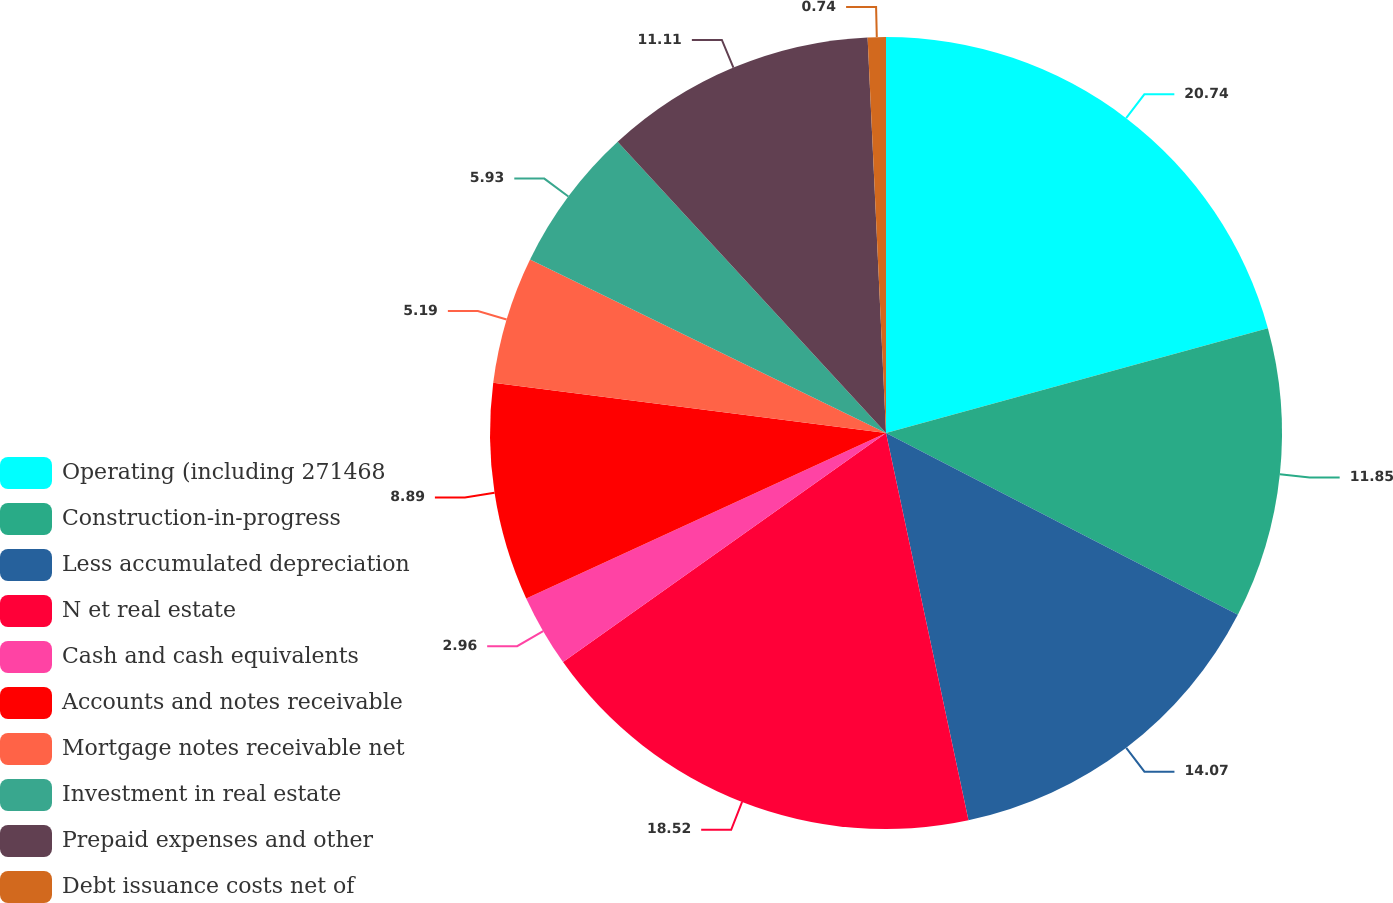Convert chart. <chart><loc_0><loc_0><loc_500><loc_500><pie_chart><fcel>Operating (including 271468<fcel>Construction-in-progress<fcel>Less accumulated depreciation<fcel>N et real estate<fcel>Cash and cash equivalents<fcel>Accounts and notes receivable<fcel>Mortgage notes receivable net<fcel>Investment in real estate<fcel>Prepaid expenses and other<fcel>Debt issuance costs net of<nl><fcel>20.74%<fcel>11.85%<fcel>14.07%<fcel>18.52%<fcel>2.96%<fcel>8.89%<fcel>5.19%<fcel>5.93%<fcel>11.11%<fcel>0.74%<nl></chart> 